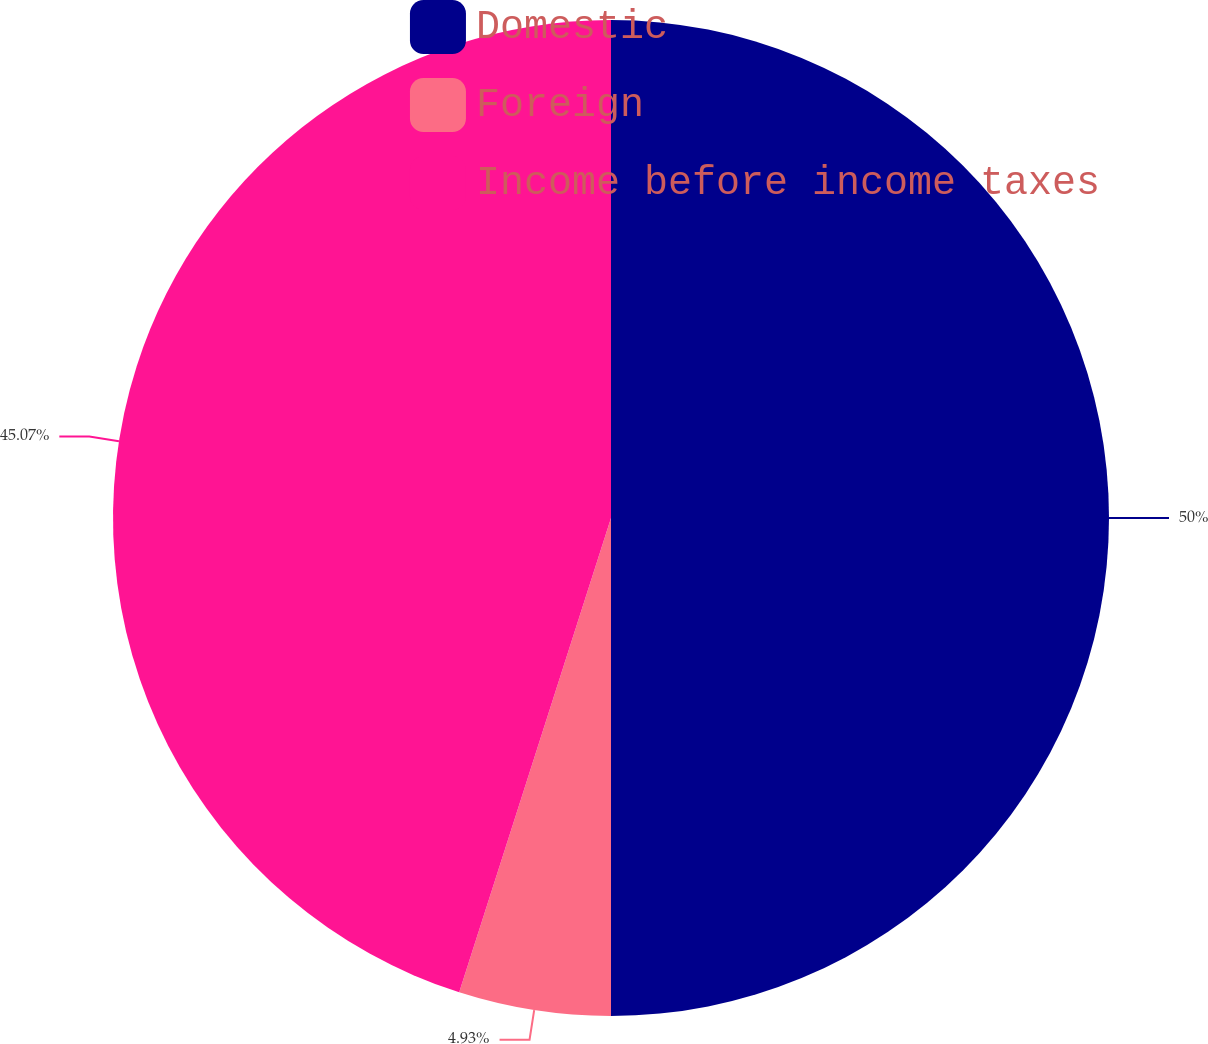Convert chart to OTSL. <chart><loc_0><loc_0><loc_500><loc_500><pie_chart><fcel>Domestic<fcel>Foreign<fcel>Income before income taxes<nl><fcel>50.0%<fcel>4.93%<fcel>45.07%<nl></chart> 